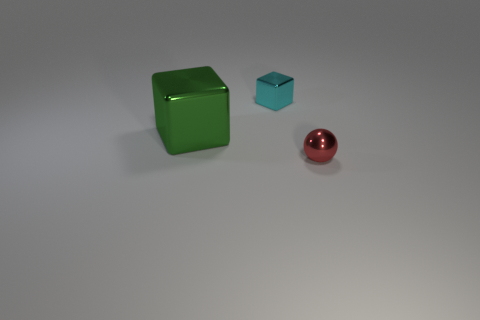There is a large green thing; how many small metal things are behind it?
Your answer should be compact. 1. There is a tiny thing on the left side of the tiny object in front of the metallic cube that is behind the green shiny thing; what color is it?
Offer a very short reply. Cyan. There is a small shiny object that is behind the tiny object that is in front of the green shiny cube; what is its shape?
Your answer should be very brief. Cube. Are there any cyan metallic cubes of the same size as the red thing?
Offer a very short reply. Yes. What number of other objects are the same shape as the large green object?
Keep it short and to the point. 1. Are there the same number of big metal cubes that are to the right of the green cube and big shiny blocks that are in front of the small cyan thing?
Offer a very short reply. No. Is there a tiny blue matte cylinder?
Your answer should be very brief. No. What is the size of the shiny block left of the tiny object that is behind the thing that is in front of the big green cube?
Keep it short and to the point. Large. What is the shape of the other thing that is the same size as the red thing?
Make the answer very short. Cube. How many objects are shiny objects that are to the right of the small block or brown rubber objects?
Offer a very short reply. 1. 